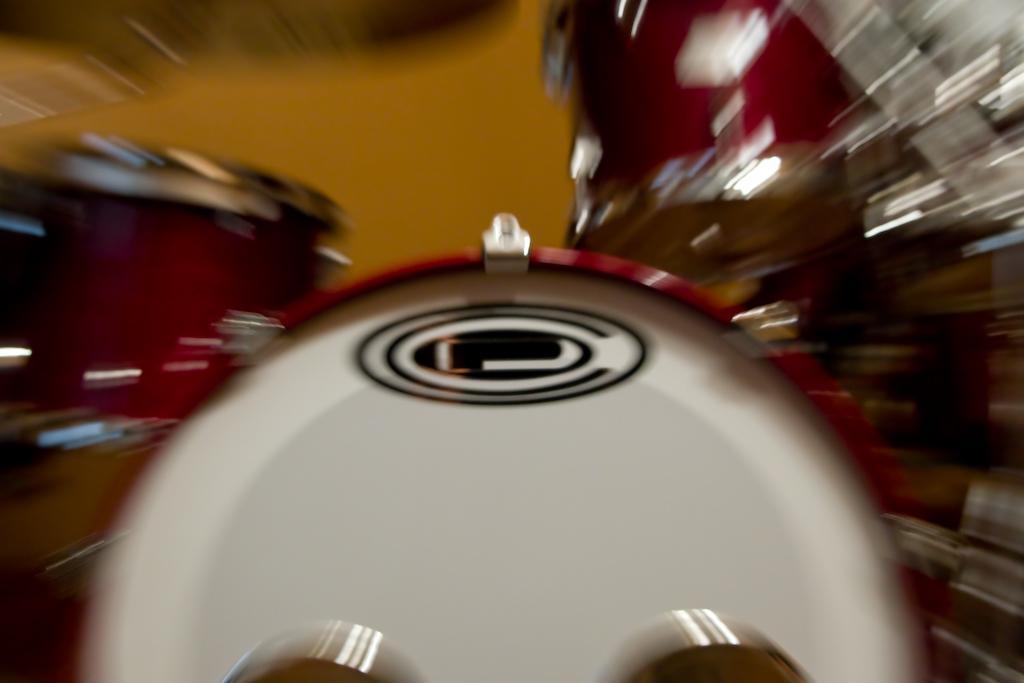Please provide a concise description of this image. This picture is blur, in this picture we can see musical instruments. 